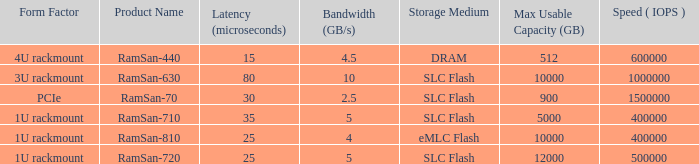What is the Input/output operations per second for the emlc flash? 400000.0. 